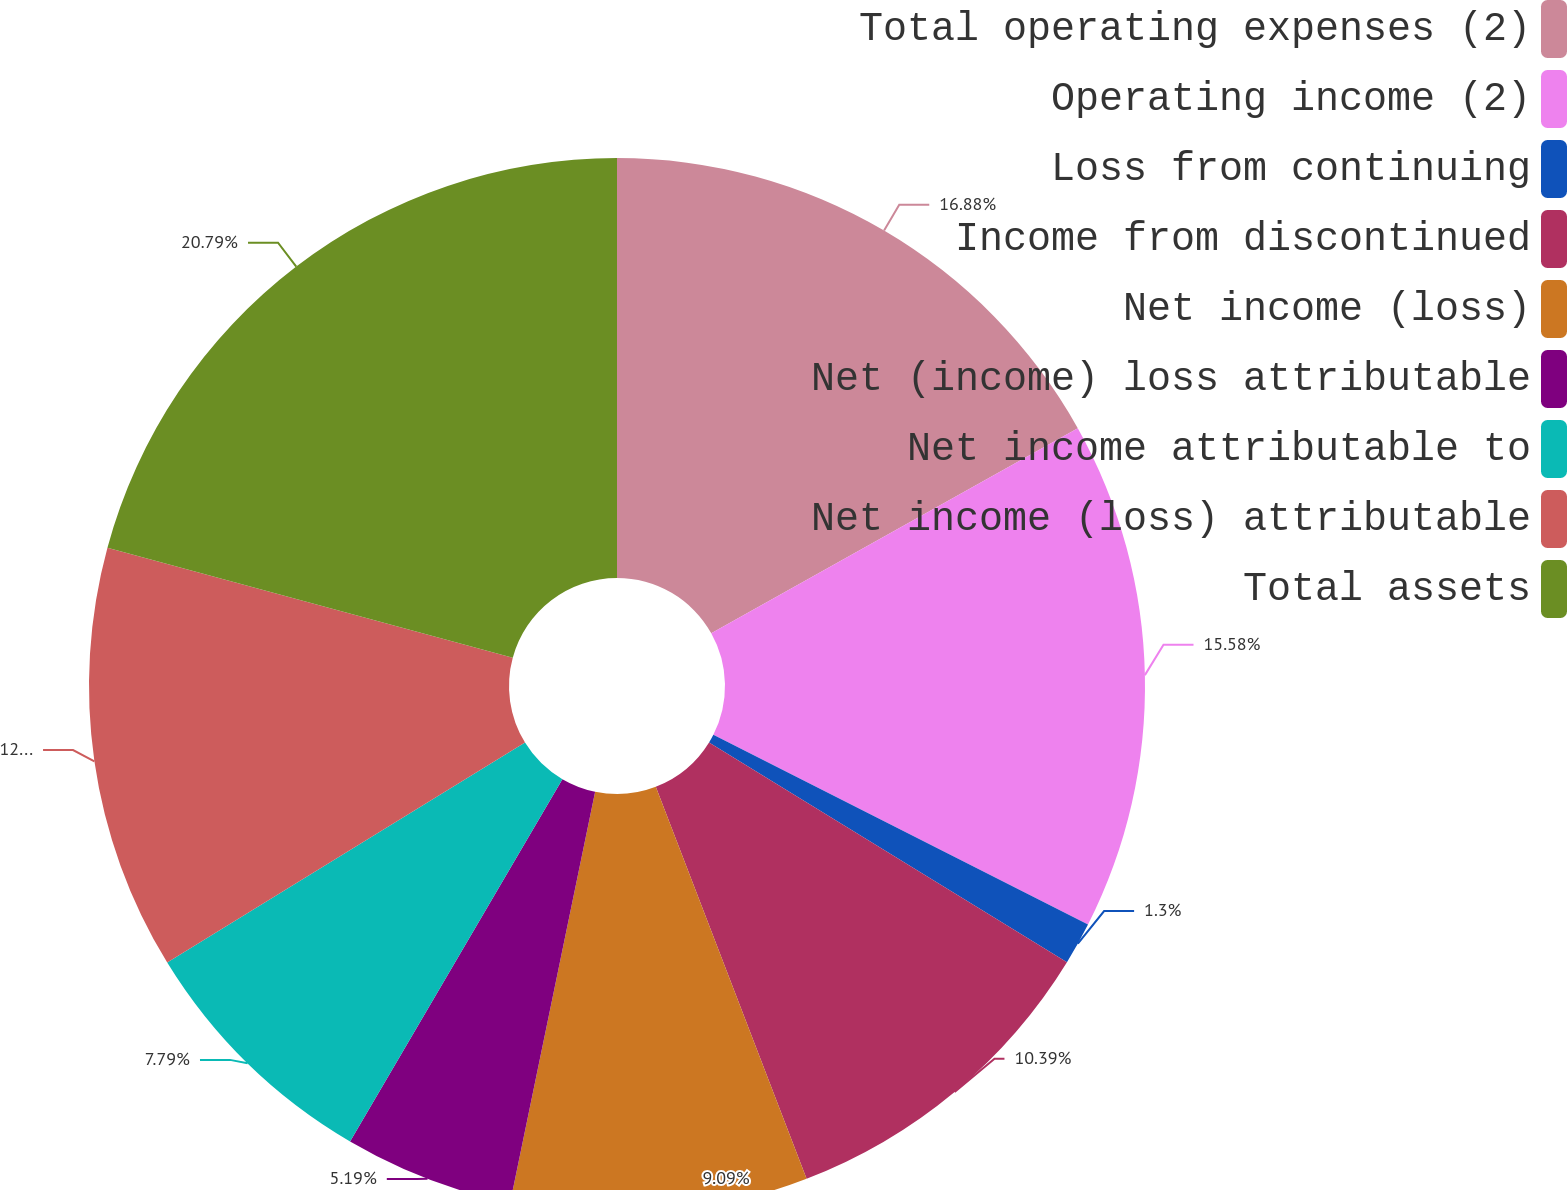<chart> <loc_0><loc_0><loc_500><loc_500><pie_chart><fcel>Total operating expenses (2)<fcel>Operating income (2)<fcel>Loss from continuing<fcel>Income from discontinued<fcel>Net income (loss)<fcel>Net (income) loss attributable<fcel>Net income attributable to<fcel>Net income (loss) attributable<fcel>Total assets<nl><fcel>16.88%<fcel>15.58%<fcel>1.3%<fcel>10.39%<fcel>9.09%<fcel>5.19%<fcel>7.79%<fcel>12.99%<fcel>20.78%<nl></chart> 